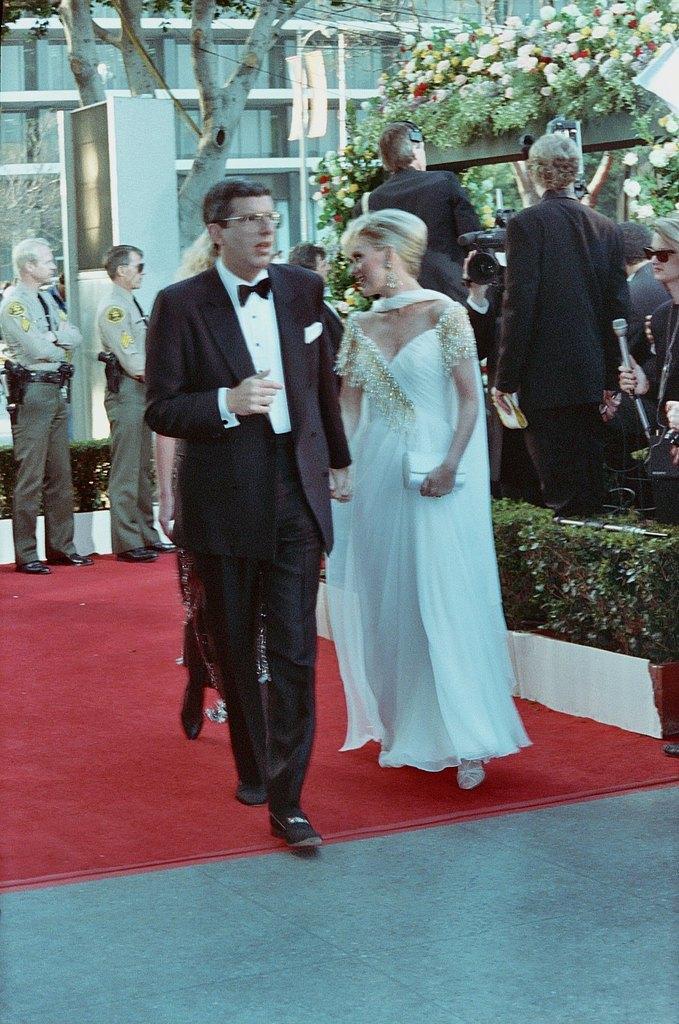Describe this image in one or two sentences. In this image, there are a few people. We can see the ground with an object. We can see some plants and flowers. We can see the glass building. We can also see a pole and the trunk of the tree. We can also see a white colored object. 